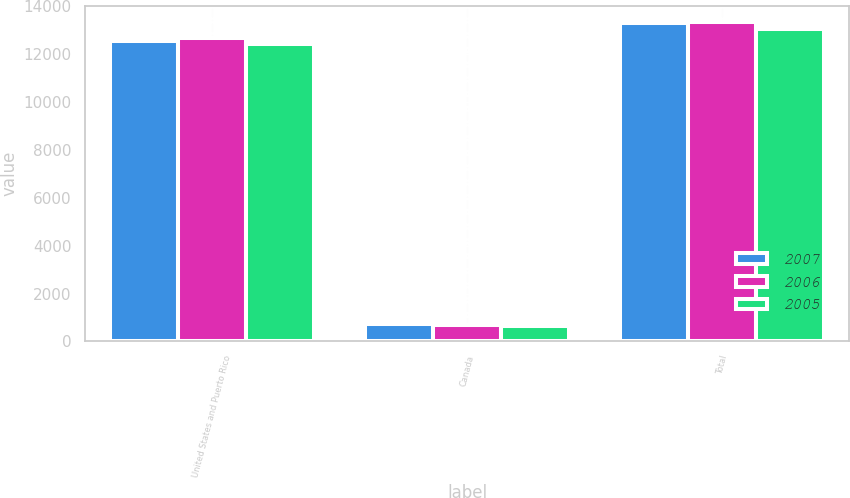Convert chart. <chart><loc_0><loc_0><loc_500><loc_500><stacked_bar_chart><ecel><fcel>United States and Puerto Rico<fcel>Canada<fcel>Total<nl><fcel>2007<fcel>12566<fcel>744<fcel>13310<nl><fcel>2006<fcel>12674<fcel>689<fcel>13363<nl><fcel>2005<fcel>12430<fcel>644<fcel>13074<nl></chart> 